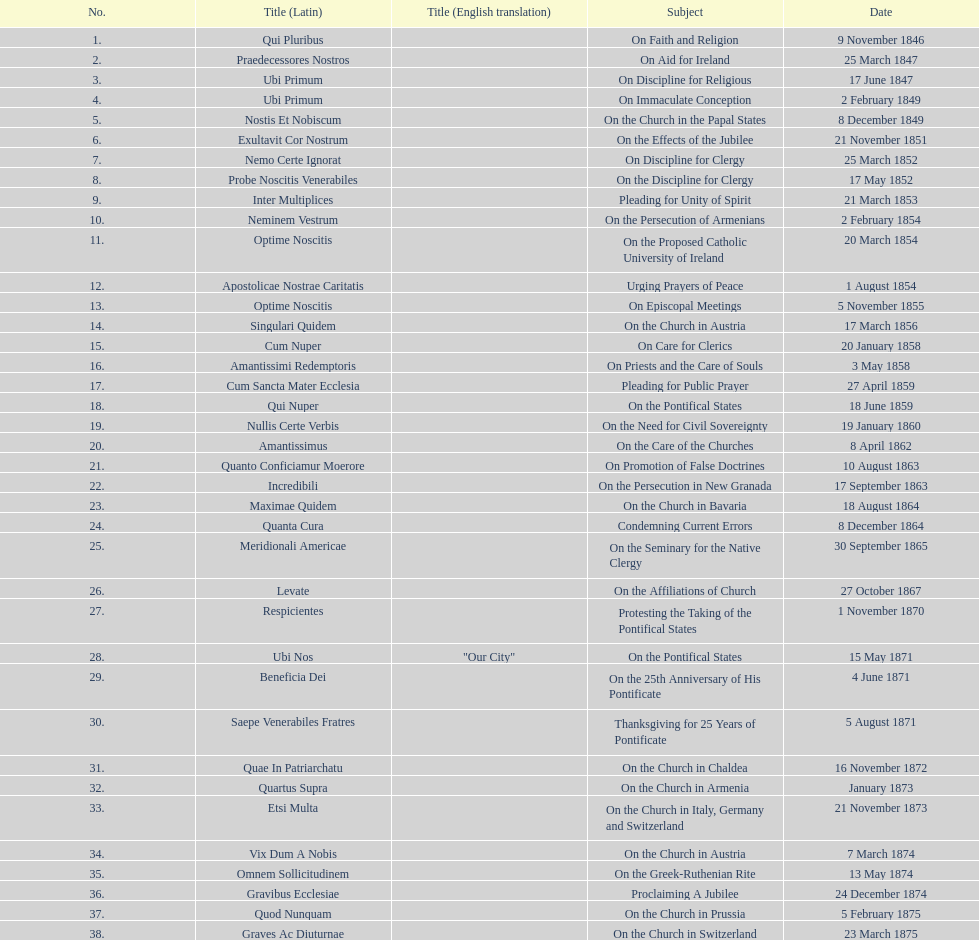How many encyclicals were issued by pope pius ix within the first ten years of his reign? 14. 